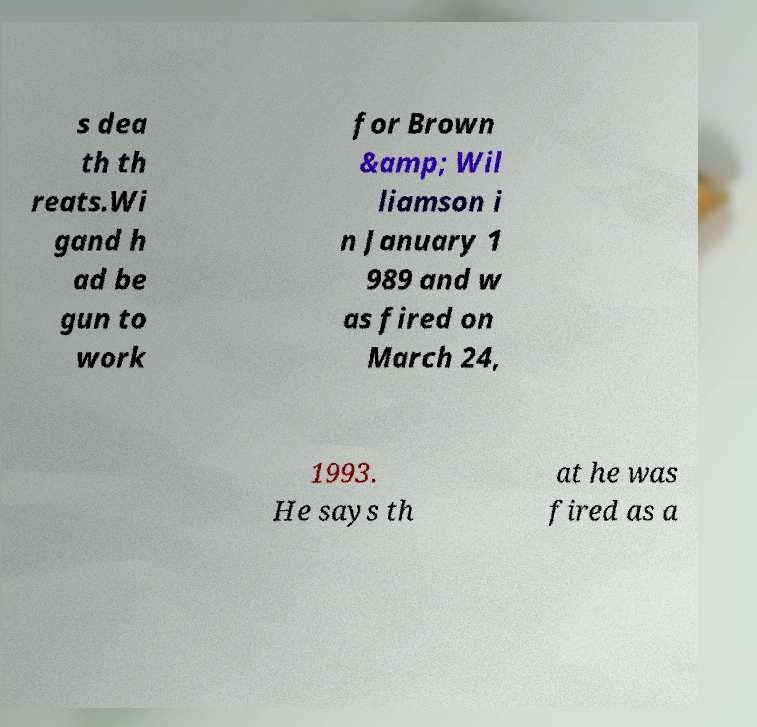Could you extract and type out the text from this image? s dea th th reats.Wi gand h ad be gun to work for Brown &amp; Wil liamson i n January 1 989 and w as fired on March 24, 1993. He says th at he was fired as a 